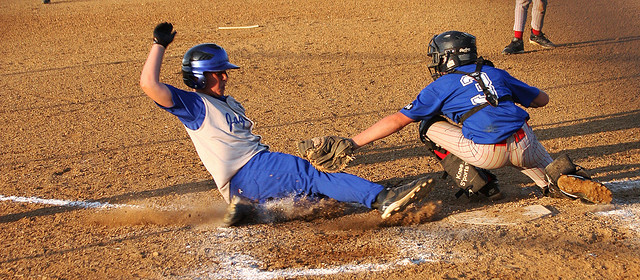Read and extract the text from this image. 3 